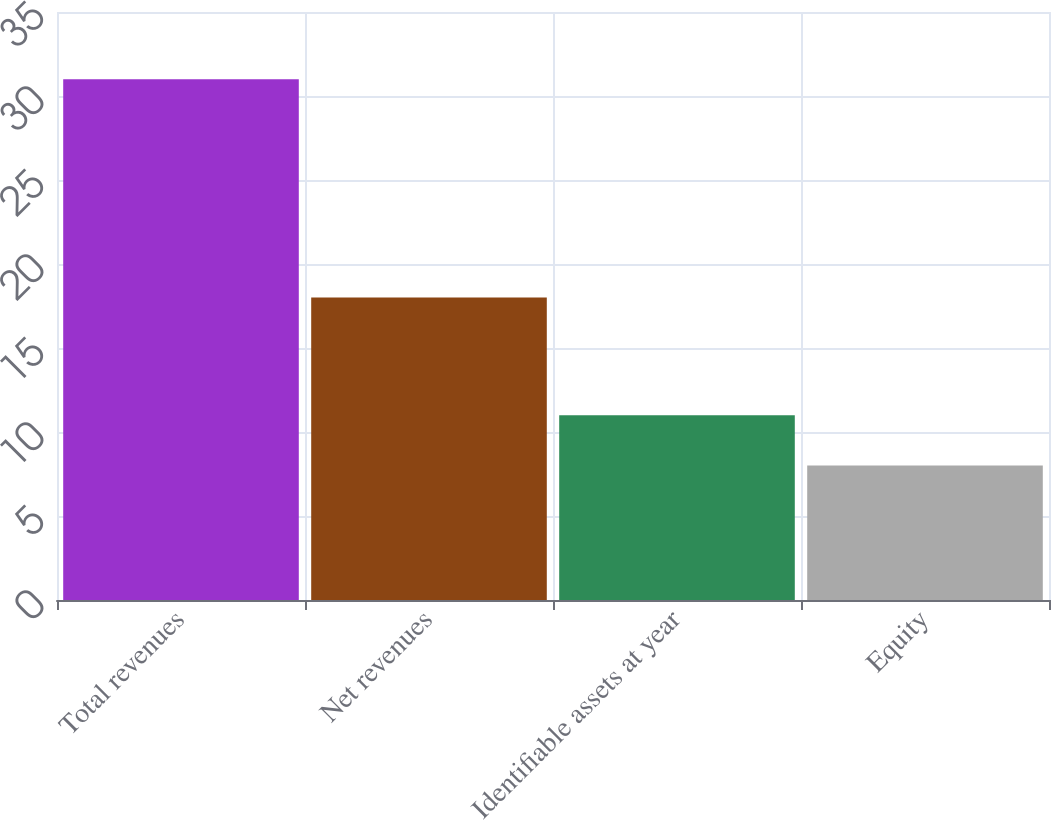<chart> <loc_0><loc_0><loc_500><loc_500><bar_chart><fcel>Total revenues<fcel>Net revenues<fcel>Identifiable assets at year<fcel>Equity<nl><fcel>31<fcel>18<fcel>11<fcel>8<nl></chart> 